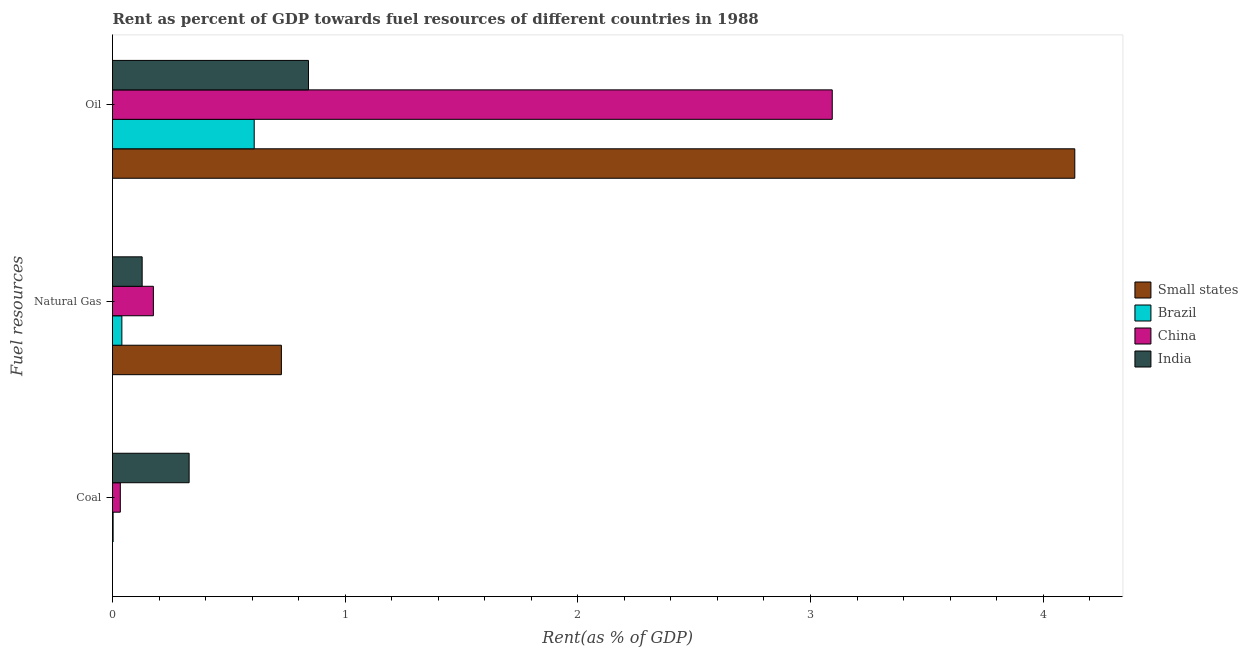How many groups of bars are there?
Offer a very short reply. 3. Are the number of bars per tick equal to the number of legend labels?
Give a very brief answer. Yes. Are the number of bars on each tick of the Y-axis equal?
Offer a terse response. Yes. How many bars are there on the 1st tick from the bottom?
Keep it short and to the point. 4. What is the label of the 2nd group of bars from the top?
Make the answer very short. Natural Gas. What is the rent towards coal in China?
Your response must be concise. 0.03. Across all countries, what is the maximum rent towards natural gas?
Give a very brief answer. 0.73. Across all countries, what is the minimum rent towards natural gas?
Ensure brevity in your answer.  0.04. In which country was the rent towards oil maximum?
Give a very brief answer. Small states. In which country was the rent towards oil minimum?
Ensure brevity in your answer.  Brazil. What is the total rent towards oil in the graph?
Provide a succinct answer. 8.68. What is the difference between the rent towards natural gas in Brazil and that in China?
Your response must be concise. -0.14. What is the difference between the rent towards oil in China and the rent towards natural gas in Brazil?
Ensure brevity in your answer.  3.05. What is the average rent towards natural gas per country?
Offer a terse response. 0.27. What is the difference between the rent towards coal and rent towards natural gas in India?
Keep it short and to the point. 0.2. What is the ratio of the rent towards oil in India to that in Brazil?
Offer a terse response. 1.38. Is the difference between the rent towards coal in India and Small states greater than the difference between the rent towards oil in India and Small states?
Keep it short and to the point. Yes. What is the difference between the highest and the second highest rent towards coal?
Provide a short and direct response. 0.3. What is the difference between the highest and the lowest rent towards natural gas?
Keep it short and to the point. 0.69. What does the 2nd bar from the top in Natural Gas represents?
Ensure brevity in your answer.  China. What does the 3rd bar from the bottom in Oil represents?
Give a very brief answer. China. How many bars are there?
Your answer should be compact. 12. What is the difference between two consecutive major ticks on the X-axis?
Keep it short and to the point. 1. Are the values on the major ticks of X-axis written in scientific E-notation?
Provide a short and direct response. No. Does the graph contain grids?
Offer a very short reply. No. How are the legend labels stacked?
Offer a terse response. Vertical. What is the title of the graph?
Provide a succinct answer. Rent as percent of GDP towards fuel resources of different countries in 1988. Does "Samoa" appear as one of the legend labels in the graph?
Your response must be concise. No. What is the label or title of the X-axis?
Your answer should be very brief. Rent(as % of GDP). What is the label or title of the Y-axis?
Your response must be concise. Fuel resources. What is the Rent(as % of GDP) in Small states in Coal?
Your answer should be very brief. 3.92464681836459e-5. What is the Rent(as % of GDP) in Brazil in Coal?
Your answer should be compact. 0. What is the Rent(as % of GDP) of China in Coal?
Make the answer very short. 0.03. What is the Rent(as % of GDP) of India in Coal?
Give a very brief answer. 0.33. What is the Rent(as % of GDP) in Small states in Natural Gas?
Your answer should be very brief. 0.73. What is the Rent(as % of GDP) of Brazil in Natural Gas?
Your answer should be very brief. 0.04. What is the Rent(as % of GDP) in China in Natural Gas?
Give a very brief answer. 0.18. What is the Rent(as % of GDP) in India in Natural Gas?
Provide a short and direct response. 0.13. What is the Rent(as % of GDP) in Small states in Oil?
Provide a succinct answer. 4.14. What is the Rent(as % of GDP) in Brazil in Oil?
Keep it short and to the point. 0.61. What is the Rent(as % of GDP) of China in Oil?
Your answer should be compact. 3.09. What is the Rent(as % of GDP) of India in Oil?
Your answer should be compact. 0.84. Across all Fuel resources, what is the maximum Rent(as % of GDP) in Small states?
Your answer should be very brief. 4.14. Across all Fuel resources, what is the maximum Rent(as % of GDP) in Brazil?
Your answer should be very brief. 0.61. Across all Fuel resources, what is the maximum Rent(as % of GDP) of China?
Keep it short and to the point. 3.09. Across all Fuel resources, what is the maximum Rent(as % of GDP) in India?
Provide a succinct answer. 0.84. Across all Fuel resources, what is the minimum Rent(as % of GDP) of Small states?
Your answer should be very brief. 3.92464681836459e-5. Across all Fuel resources, what is the minimum Rent(as % of GDP) in Brazil?
Keep it short and to the point. 0. Across all Fuel resources, what is the minimum Rent(as % of GDP) of China?
Offer a terse response. 0.03. Across all Fuel resources, what is the minimum Rent(as % of GDP) in India?
Keep it short and to the point. 0.13. What is the total Rent(as % of GDP) of Small states in the graph?
Ensure brevity in your answer.  4.86. What is the total Rent(as % of GDP) of Brazil in the graph?
Give a very brief answer. 0.65. What is the total Rent(as % of GDP) in China in the graph?
Ensure brevity in your answer.  3.3. What is the total Rent(as % of GDP) in India in the graph?
Your response must be concise. 1.3. What is the difference between the Rent(as % of GDP) of Small states in Coal and that in Natural Gas?
Provide a short and direct response. -0.73. What is the difference between the Rent(as % of GDP) in Brazil in Coal and that in Natural Gas?
Provide a succinct answer. -0.04. What is the difference between the Rent(as % of GDP) in China in Coal and that in Natural Gas?
Offer a very short reply. -0.14. What is the difference between the Rent(as % of GDP) in India in Coal and that in Natural Gas?
Ensure brevity in your answer.  0.2. What is the difference between the Rent(as % of GDP) in Small states in Coal and that in Oil?
Your answer should be very brief. -4.14. What is the difference between the Rent(as % of GDP) in Brazil in Coal and that in Oil?
Make the answer very short. -0.61. What is the difference between the Rent(as % of GDP) in China in Coal and that in Oil?
Provide a succinct answer. -3.06. What is the difference between the Rent(as % of GDP) of India in Coal and that in Oil?
Keep it short and to the point. -0.51. What is the difference between the Rent(as % of GDP) in Small states in Natural Gas and that in Oil?
Your answer should be very brief. -3.41. What is the difference between the Rent(as % of GDP) of Brazil in Natural Gas and that in Oil?
Ensure brevity in your answer.  -0.57. What is the difference between the Rent(as % of GDP) in China in Natural Gas and that in Oil?
Make the answer very short. -2.92. What is the difference between the Rent(as % of GDP) of India in Natural Gas and that in Oil?
Make the answer very short. -0.71. What is the difference between the Rent(as % of GDP) in Small states in Coal and the Rent(as % of GDP) in Brazil in Natural Gas?
Make the answer very short. -0.04. What is the difference between the Rent(as % of GDP) in Small states in Coal and the Rent(as % of GDP) in China in Natural Gas?
Your response must be concise. -0.18. What is the difference between the Rent(as % of GDP) of Small states in Coal and the Rent(as % of GDP) of India in Natural Gas?
Offer a very short reply. -0.13. What is the difference between the Rent(as % of GDP) in Brazil in Coal and the Rent(as % of GDP) in China in Natural Gas?
Offer a very short reply. -0.17. What is the difference between the Rent(as % of GDP) of Brazil in Coal and the Rent(as % of GDP) of India in Natural Gas?
Provide a short and direct response. -0.12. What is the difference between the Rent(as % of GDP) of China in Coal and the Rent(as % of GDP) of India in Natural Gas?
Provide a succinct answer. -0.09. What is the difference between the Rent(as % of GDP) in Small states in Coal and the Rent(as % of GDP) in Brazil in Oil?
Keep it short and to the point. -0.61. What is the difference between the Rent(as % of GDP) in Small states in Coal and the Rent(as % of GDP) in China in Oil?
Your response must be concise. -3.09. What is the difference between the Rent(as % of GDP) of Small states in Coal and the Rent(as % of GDP) of India in Oil?
Keep it short and to the point. -0.84. What is the difference between the Rent(as % of GDP) in Brazil in Coal and the Rent(as % of GDP) in China in Oil?
Your response must be concise. -3.09. What is the difference between the Rent(as % of GDP) in Brazil in Coal and the Rent(as % of GDP) in India in Oil?
Keep it short and to the point. -0.84. What is the difference between the Rent(as % of GDP) of China in Coal and the Rent(as % of GDP) of India in Oil?
Make the answer very short. -0.81. What is the difference between the Rent(as % of GDP) of Small states in Natural Gas and the Rent(as % of GDP) of Brazil in Oil?
Offer a very short reply. 0.12. What is the difference between the Rent(as % of GDP) of Small states in Natural Gas and the Rent(as % of GDP) of China in Oil?
Ensure brevity in your answer.  -2.37. What is the difference between the Rent(as % of GDP) in Small states in Natural Gas and the Rent(as % of GDP) in India in Oil?
Keep it short and to the point. -0.12. What is the difference between the Rent(as % of GDP) of Brazil in Natural Gas and the Rent(as % of GDP) of China in Oil?
Give a very brief answer. -3.05. What is the difference between the Rent(as % of GDP) in Brazil in Natural Gas and the Rent(as % of GDP) in India in Oil?
Offer a very short reply. -0.8. What is the difference between the Rent(as % of GDP) in China in Natural Gas and the Rent(as % of GDP) in India in Oil?
Provide a short and direct response. -0.67. What is the average Rent(as % of GDP) in Small states per Fuel resources?
Your response must be concise. 1.62. What is the average Rent(as % of GDP) in Brazil per Fuel resources?
Offer a very short reply. 0.22. What is the average Rent(as % of GDP) in China per Fuel resources?
Give a very brief answer. 1.1. What is the average Rent(as % of GDP) in India per Fuel resources?
Make the answer very short. 0.43. What is the difference between the Rent(as % of GDP) in Small states and Rent(as % of GDP) in Brazil in Coal?
Give a very brief answer. -0. What is the difference between the Rent(as % of GDP) of Small states and Rent(as % of GDP) of China in Coal?
Your response must be concise. -0.03. What is the difference between the Rent(as % of GDP) of Small states and Rent(as % of GDP) of India in Coal?
Give a very brief answer. -0.33. What is the difference between the Rent(as % of GDP) of Brazil and Rent(as % of GDP) of China in Coal?
Make the answer very short. -0.03. What is the difference between the Rent(as % of GDP) in Brazil and Rent(as % of GDP) in India in Coal?
Your answer should be very brief. -0.33. What is the difference between the Rent(as % of GDP) in China and Rent(as % of GDP) in India in Coal?
Your answer should be very brief. -0.3. What is the difference between the Rent(as % of GDP) in Small states and Rent(as % of GDP) in Brazil in Natural Gas?
Keep it short and to the point. 0.69. What is the difference between the Rent(as % of GDP) in Small states and Rent(as % of GDP) in China in Natural Gas?
Provide a short and direct response. 0.55. What is the difference between the Rent(as % of GDP) of Small states and Rent(as % of GDP) of India in Natural Gas?
Your answer should be compact. 0.6. What is the difference between the Rent(as % of GDP) in Brazil and Rent(as % of GDP) in China in Natural Gas?
Make the answer very short. -0.14. What is the difference between the Rent(as % of GDP) in Brazil and Rent(as % of GDP) in India in Natural Gas?
Your answer should be compact. -0.09. What is the difference between the Rent(as % of GDP) in China and Rent(as % of GDP) in India in Natural Gas?
Provide a short and direct response. 0.05. What is the difference between the Rent(as % of GDP) in Small states and Rent(as % of GDP) in Brazil in Oil?
Your answer should be compact. 3.53. What is the difference between the Rent(as % of GDP) in Small states and Rent(as % of GDP) in China in Oil?
Provide a short and direct response. 1.04. What is the difference between the Rent(as % of GDP) of Small states and Rent(as % of GDP) of India in Oil?
Your response must be concise. 3.29. What is the difference between the Rent(as % of GDP) in Brazil and Rent(as % of GDP) in China in Oil?
Keep it short and to the point. -2.48. What is the difference between the Rent(as % of GDP) of Brazil and Rent(as % of GDP) of India in Oil?
Make the answer very short. -0.23. What is the difference between the Rent(as % of GDP) in China and Rent(as % of GDP) in India in Oil?
Make the answer very short. 2.25. What is the ratio of the Rent(as % of GDP) in Small states in Coal to that in Natural Gas?
Keep it short and to the point. 0. What is the ratio of the Rent(as % of GDP) in Brazil in Coal to that in Natural Gas?
Provide a short and direct response. 0.07. What is the ratio of the Rent(as % of GDP) in China in Coal to that in Natural Gas?
Your answer should be compact. 0.19. What is the ratio of the Rent(as % of GDP) of India in Coal to that in Natural Gas?
Offer a very short reply. 2.58. What is the ratio of the Rent(as % of GDP) of Brazil in Coal to that in Oil?
Keep it short and to the point. 0. What is the ratio of the Rent(as % of GDP) in China in Coal to that in Oil?
Offer a very short reply. 0.01. What is the ratio of the Rent(as % of GDP) in India in Coal to that in Oil?
Offer a terse response. 0.39. What is the ratio of the Rent(as % of GDP) in Small states in Natural Gas to that in Oil?
Your answer should be very brief. 0.18. What is the ratio of the Rent(as % of GDP) in Brazil in Natural Gas to that in Oil?
Keep it short and to the point. 0.07. What is the ratio of the Rent(as % of GDP) in China in Natural Gas to that in Oil?
Offer a terse response. 0.06. What is the ratio of the Rent(as % of GDP) in India in Natural Gas to that in Oil?
Offer a very short reply. 0.15. What is the difference between the highest and the second highest Rent(as % of GDP) in Small states?
Provide a succinct answer. 3.41. What is the difference between the highest and the second highest Rent(as % of GDP) of Brazil?
Provide a short and direct response. 0.57. What is the difference between the highest and the second highest Rent(as % of GDP) in China?
Your answer should be compact. 2.92. What is the difference between the highest and the second highest Rent(as % of GDP) of India?
Provide a short and direct response. 0.51. What is the difference between the highest and the lowest Rent(as % of GDP) of Small states?
Your answer should be compact. 4.14. What is the difference between the highest and the lowest Rent(as % of GDP) of Brazil?
Your answer should be very brief. 0.61. What is the difference between the highest and the lowest Rent(as % of GDP) in China?
Ensure brevity in your answer.  3.06. What is the difference between the highest and the lowest Rent(as % of GDP) of India?
Ensure brevity in your answer.  0.71. 